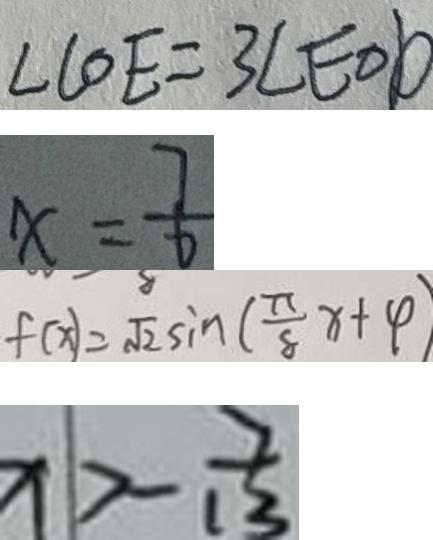Convert formula to latex. <formula><loc_0><loc_0><loc_500><loc_500>\angle C O E = 3 \angle E O D 
 x = \frac { 7 } { 6 } 
 f ( x ) = \sqrt { 2 } \sin ( \frac { \pi } { 8 } x + \varphi ) 
 x > - \frac { 7 } { 1 3 }</formula> 